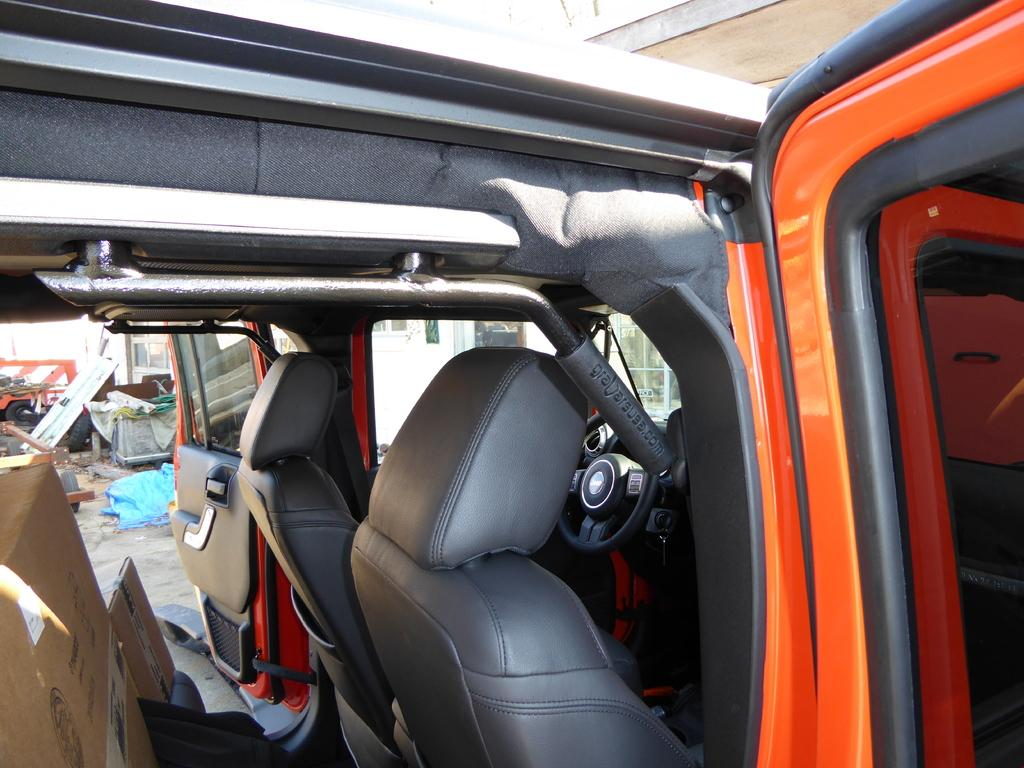What is the main subject of the image? The main subject of the image is a car. What is the color of the car? The car is orange in color. What can be found inside the car? There are seats inside the car. What type of meat can be seen hanging from the car in the image? There is no meat or flesh present in the image, and the car is not associated with a farm. 